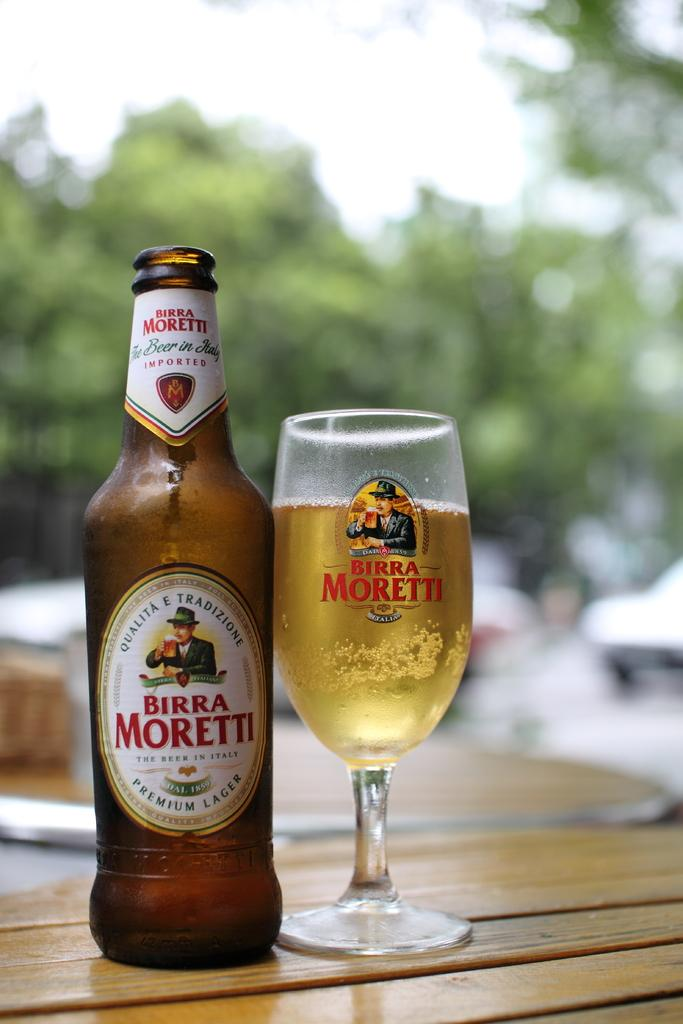<image>
Write a terse but informative summary of the picture. A bottle of Birra Moretti has been poured into a glass at an outdoor table 